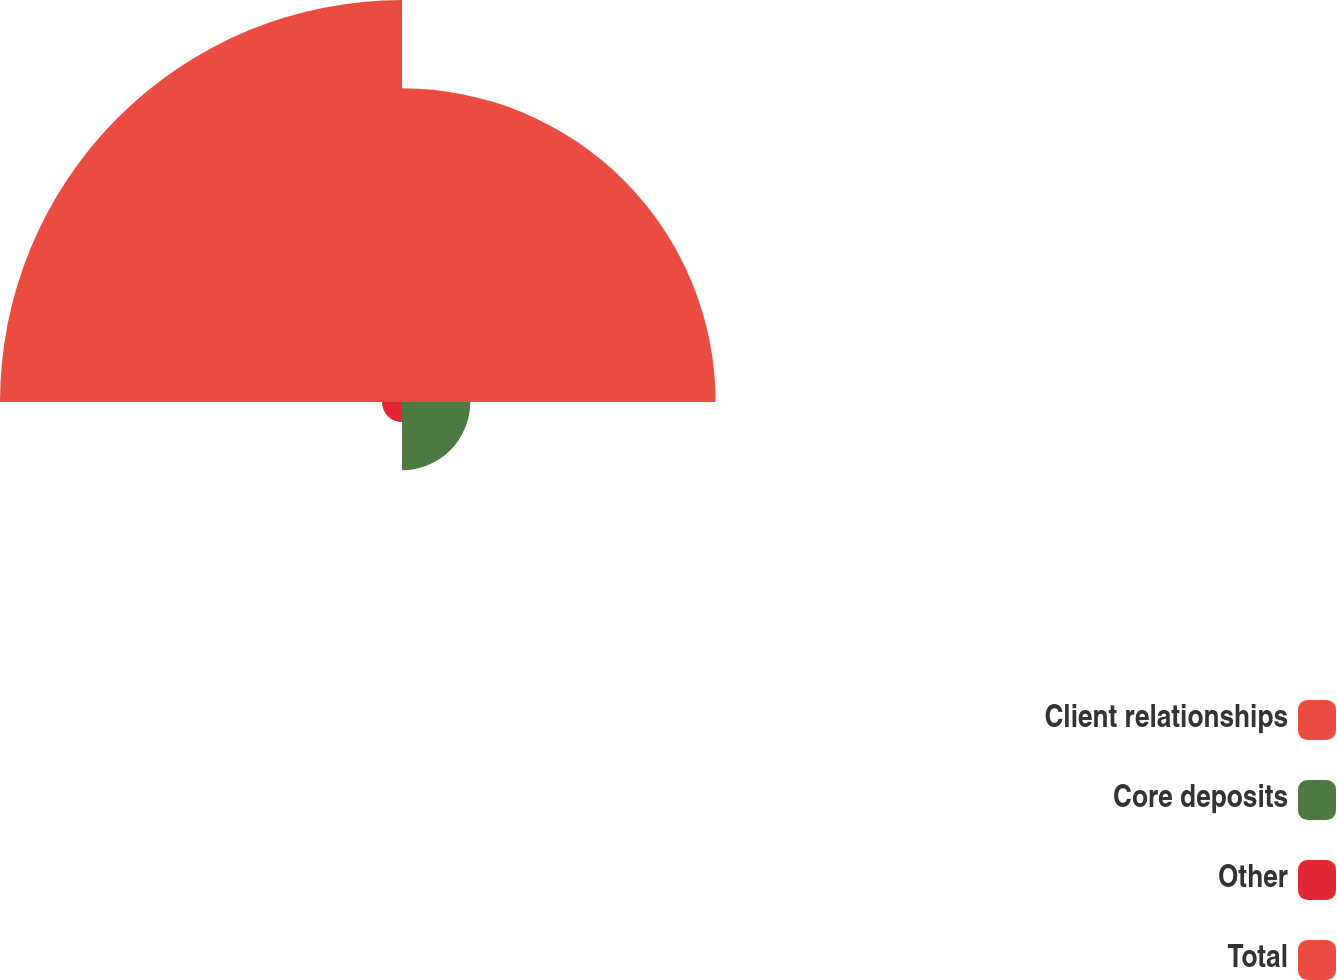Convert chart to OTSL. <chart><loc_0><loc_0><loc_500><loc_500><pie_chart><fcel>Client relationships<fcel>Core deposits<fcel>Other<fcel>Total<nl><fcel>39.01%<fcel>8.49%<fcel>2.49%<fcel>50.0%<nl></chart> 